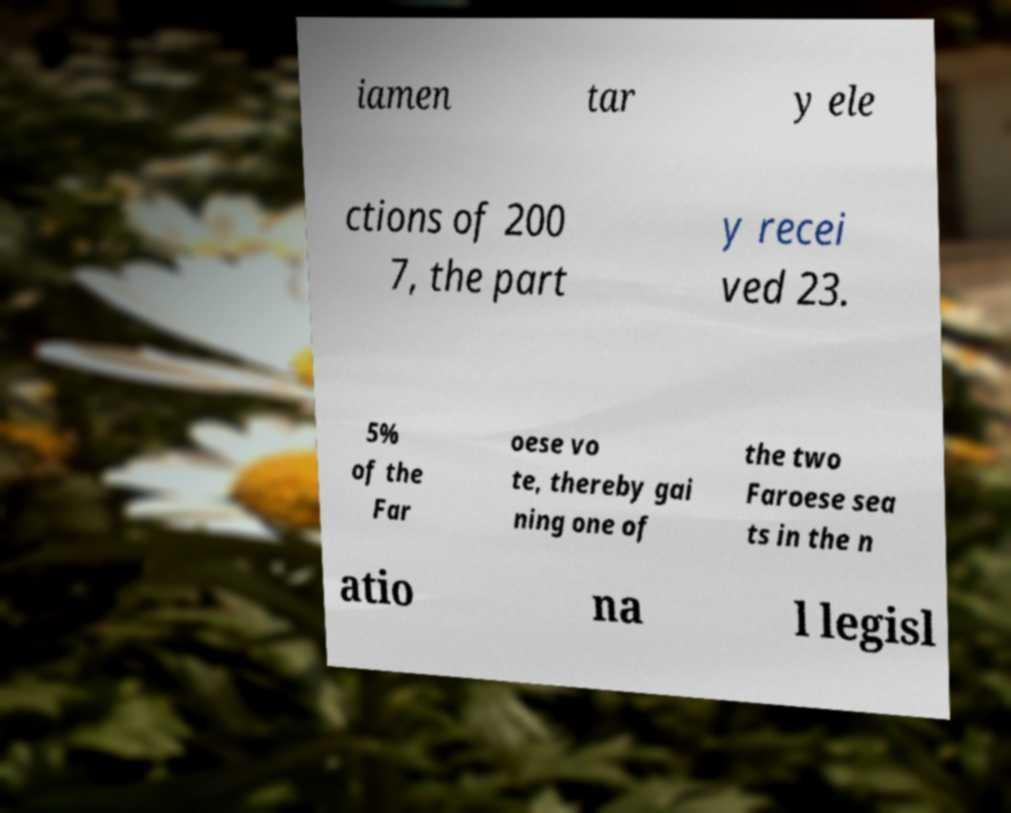I need the written content from this picture converted into text. Can you do that? iamen tar y ele ctions of 200 7, the part y recei ved 23. 5% of the Far oese vo te, thereby gai ning one of the two Faroese sea ts in the n atio na l legisl 